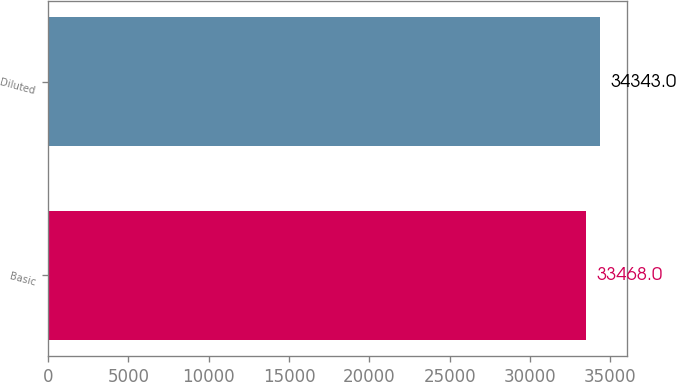Convert chart. <chart><loc_0><loc_0><loc_500><loc_500><bar_chart><fcel>Basic<fcel>Diluted<nl><fcel>33468<fcel>34343<nl></chart> 